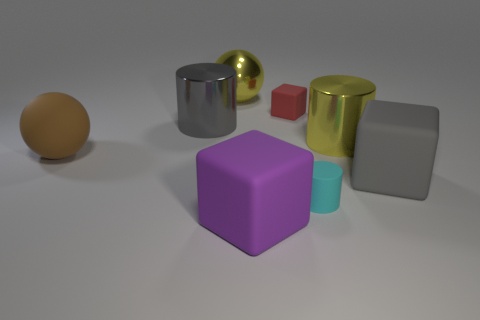Is there a shiny thing of the same color as the metallic sphere?
Offer a terse response. Yes. There is a block behind the big rubber object on the right side of the purple cube; what is its color?
Provide a succinct answer. Red. Is the number of gray metallic objects that are to the left of the brown thing less than the number of rubber objects that are left of the big yellow sphere?
Make the answer very short. Yes. Is the size of the cyan object the same as the red cube?
Make the answer very short. Yes. What shape is the metal object that is in front of the big yellow metal ball and left of the purple thing?
Your answer should be very brief. Cylinder. How many large gray blocks have the same material as the tiny red cube?
Offer a terse response. 1. There is a shiny cylinder that is on the left side of the yellow sphere; what number of yellow cylinders are to the right of it?
Offer a very short reply. 1. What shape is the big yellow metallic thing that is on the right side of the matte block that is to the left of the red thing right of the big gray cylinder?
Give a very brief answer. Cylinder. What is the size of the metallic cylinder that is the same color as the metallic ball?
Provide a short and direct response. Large. There is a metallic sphere that is the same size as the rubber sphere; what color is it?
Make the answer very short. Yellow. 